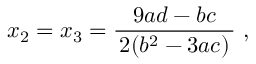<formula> <loc_0><loc_0><loc_500><loc_500>x _ { 2 } = x _ { 3 } = { \frac { 9 a d - b c } { \, 2 ( b ^ { 2 } - 3 a c ) \, } } ,</formula> 